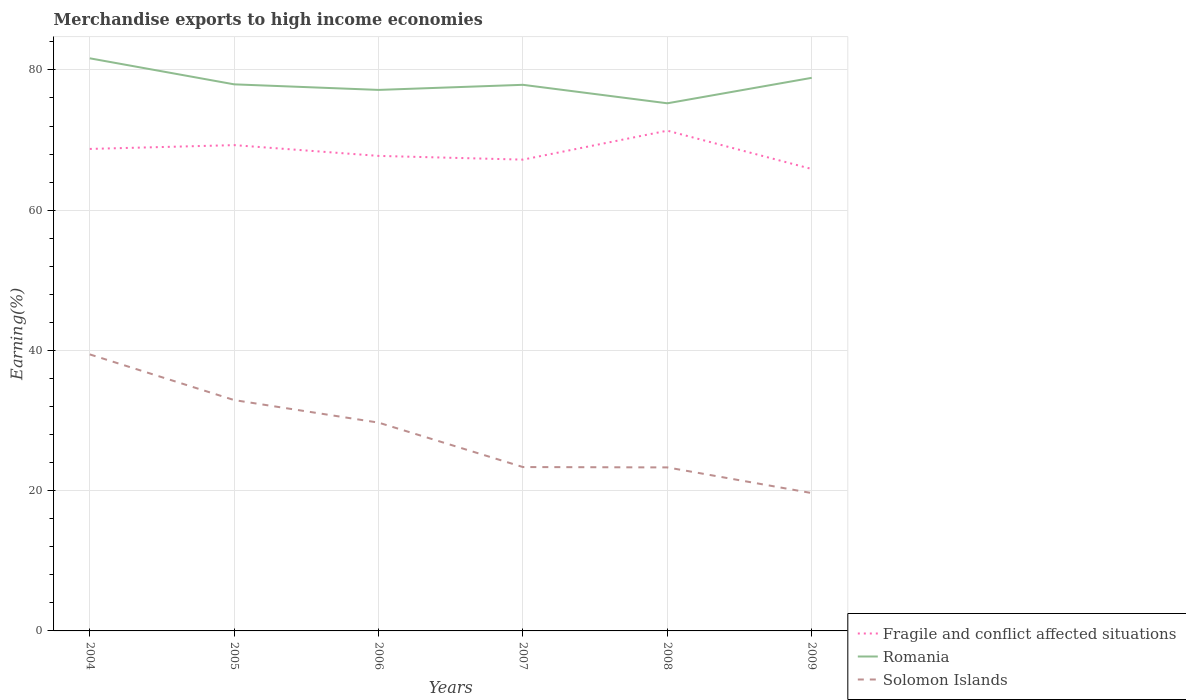Across all years, what is the maximum percentage of amount earned from merchandise exports in Solomon Islands?
Make the answer very short. 19.66. In which year was the percentage of amount earned from merchandise exports in Solomon Islands maximum?
Provide a short and direct response. 2009. What is the total percentage of amount earned from merchandise exports in Solomon Islands in the graph?
Give a very brief answer. 16.12. What is the difference between the highest and the second highest percentage of amount earned from merchandise exports in Solomon Islands?
Your answer should be very brief. 19.77. What is the difference between the highest and the lowest percentage of amount earned from merchandise exports in Romania?
Give a very brief answer. 2. Is the percentage of amount earned from merchandise exports in Solomon Islands strictly greater than the percentage of amount earned from merchandise exports in Romania over the years?
Offer a very short reply. Yes. How many years are there in the graph?
Make the answer very short. 6. Are the values on the major ticks of Y-axis written in scientific E-notation?
Your answer should be compact. No. Does the graph contain any zero values?
Your response must be concise. No. How are the legend labels stacked?
Ensure brevity in your answer.  Vertical. What is the title of the graph?
Ensure brevity in your answer.  Merchandise exports to high income economies. What is the label or title of the Y-axis?
Ensure brevity in your answer.  Earning(%). What is the Earning(%) of Fragile and conflict affected situations in 2004?
Offer a terse response. 68.73. What is the Earning(%) of Romania in 2004?
Keep it short and to the point. 81.66. What is the Earning(%) of Solomon Islands in 2004?
Make the answer very short. 39.43. What is the Earning(%) of Fragile and conflict affected situations in 2005?
Keep it short and to the point. 69.28. What is the Earning(%) of Romania in 2005?
Provide a short and direct response. 77.94. What is the Earning(%) of Solomon Islands in 2005?
Your answer should be compact. 32.92. What is the Earning(%) in Fragile and conflict affected situations in 2006?
Make the answer very short. 67.74. What is the Earning(%) of Romania in 2006?
Your answer should be very brief. 77.15. What is the Earning(%) in Solomon Islands in 2006?
Provide a succinct answer. 29.7. What is the Earning(%) of Fragile and conflict affected situations in 2007?
Make the answer very short. 67.21. What is the Earning(%) in Romania in 2007?
Provide a succinct answer. 77.88. What is the Earning(%) in Solomon Islands in 2007?
Give a very brief answer. 23.37. What is the Earning(%) of Fragile and conflict affected situations in 2008?
Give a very brief answer. 71.34. What is the Earning(%) in Romania in 2008?
Provide a short and direct response. 75.24. What is the Earning(%) in Solomon Islands in 2008?
Provide a short and direct response. 23.32. What is the Earning(%) of Fragile and conflict affected situations in 2009?
Offer a terse response. 65.87. What is the Earning(%) of Romania in 2009?
Give a very brief answer. 78.87. What is the Earning(%) of Solomon Islands in 2009?
Make the answer very short. 19.66. Across all years, what is the maximum Earning(%) of Fragile and conflict affected situations?
Make the answer very short. 71.34. Across all years, what is the maximum Earning(%) in Romania?
Provide a succinct answer. 81.66. Across all years, what is the maximum Earning(%) in Solomon Islands?
Your response must be concise. 39.43. Across all years, what is the minimum Earning(%) in Fragile and conflict affected situations?
Offer a very short reply. 65.87. Across all years, what is the minimum Earning(%) of Romania?
Ensure brevity in your answer.  75.24. Across all years, what is the minimum Earning(%) of Solomon Islands?
Ensure brevity in your answer.  19.66. What is the total Earning(%) in Fragile and conflict affected situations in the graph?
Provide a short and direct response. 410.17. What is the total Earning(%) of Romania in the graph?
Give a very brief answer. 468.74. What is the total Earning(%) of Solomon Islands in the graph?
Ensure brevity in your answer.  168.4. What is the difference between the Earning(%) in Fragile and conflict affected situations in 2004 and that in 2005?
Give a very brief answer. -0.54. What is the difference between the Earning(%) in Romania in 2004 and that in 2005?
Provide a short and direct response. 3.71. What is the difference between the Earning(%) in Solomon Islands in 2004 and that in 2005?
Give a very brief answer. 6.51. What is the difference between the Earning(%) of Fragile and conflict affected situations in 2004 and that in 2006?
Offer a terse response. 0.99. What is the difference between the Earning(%) of Romania in 2004 and that in 2006?
Your answer should be very brief. 4.5. What is the difference between the Earning(%) of Solomon Islands in 2004 and that in 2006?
Your answer should be compact. 9.73. What is the difference between the Earning(%) of Fragile and conflict affected situations in 2004 and that in 2007?
Your answer should be very brief. 1.53. What is the difference between the Earning(%) in Romania in 2004 and that in 2007?
Your answer should be very brief. 3.78. What is the difference between the Earning(%) of Solomon Islands in 2004 and that in 2007?
Give a very brief answer. 16.06. What is the difference between the Earning(%) of Fragile and conflict affected situations in 2004 and that in 2008?
Offer a very short reply. -2.6. What is the difference between the Earning(%) in Romania in 2004 and that in 2008?
Your response must be concise. 6.41. What is the difference between the Earning(%) in Solomon Islands in 2004 and that in 2008?
Ensure brevity in your answer.  16.12. What is the difference between the Earning(%) in Fragile and conflict affected situations in 2004 and that in 2009?
Your answer should be compact. 2.86. What is the difference between the Earning(%) of Romania in 2004 and that in 2009?
Provide a short and direct response. 2.78. What is the difference between the Earning(%) of Solomon Islands in 2004 and that in 2009?
Make the answer very short. 19.77. What is the difference between the Earning(%) of Fragile and conflict affected situations in 2005 and that in 2006?
Offer a terse response. 1.54. What is the difference between the Earning(%) in Romania in 2005 and that in 2006?
Your answer should be very brief. 0.79. What is the difference between the Earning(%) of Solomon Islands in 2005 and that in 2006?
Make the answer very short. 3.21. What is the difference between the Earning(%) in Fragile and conflict affected situations in 2005 and that in 2007?
Offer a very short reply. 2.07. What is the difference between the Earning(%) of Romania in 2005 and that in 2007?
Provide a short and direct response. 0.07. What is the difference between the Earning(%) in Solomon Islands in 2005 and that in 2007?
Ensure brevity in your answer.  9.55. What is the difference between the Earning(%) of Fragile and conflict affected situations in 2005 and that in 2008?
Give a very brief answer. -2.06. What is the difference between the Earning(%) of Romania in 2005 and that in 2008?
Provide a succinct answer. 2.7. What is the difference between the Earning(%) of Solomon Islands in 2005 and that in 2008?
Your answer should be very brief. 9.6. What is the difference between the Earning(%) of Fragile and conflict affected situations in 2005 and that in 2009?
Keep it short and to the point. 3.4. What is the difference between the Earning(%) in Romania in 2005 and that in 2009?
Provide a short and direct response. -0.93. What is the difference between the Earning(%) of Solomon Islands in 2005 and that in 2009?
Keep it short and to the point. 13.26. What is the difference between the Earning(%) of Fragile and conflict affected situations in 2006 and that in 2007?
Provide a short and direct response. 0.53. What is the difference between the Earning(%) in Romania in 2006 and that in 2007?
Offer a very short reply. -0.73. What is the difference between the Earning(%) of Solomon Islands in 2006 and that in 2007?
Offer a terse response. 6.34. What is the difference between the Earning(%) of Fragile and conflict affected situations in 2006 and that in 2008?
Provide a short and direct response. -3.6. What is the difference between the Earning(%) in Romania in 2006 and that in 2008?
Provide a succinct answer. 1.91. What is the difference between the Earning(%) in Solomon Islands in 2006 and that in 2008?
Your answer should be very brief. 6.39. What is the difference between the Earning(%) in Fragile and conflict affected situations in 2006 and that in 2009?
Provide a succinct answer. 1.87. What is the difference between the Earning(%) of Romania in 2006 and that in 2009?
Your response must be concise. -1.72. What is the difference between the Earning(%) of Solomon Islands in 2006 and that in 2009?
Provide a succinct answer. 10.05. What is the difference between the Earning(%) in Fragile and conflict affected situations in 2007 and that in 2008?
Ensure brevity in your answer.  -4.13. What is the difference between the Earning(%) in Romania in 2007 and that in 2008?
Your answer should be compact. 2.63. What is the difference between the Earning(%) of Solomon Islands in 2007 and that in 2008?
Provide a short and direct response. 0.05. What is the difference between the Earning(%) in Fragile and conflict affected situations in 2007 and that in 2009?
Give a very brief answer. 1.33. What is the difference between the Earning(%) of Romania in 2007 and that in 2009?
Your response must be concise. -1. What is the difference between the Earning(%) in Solomon Islands in 2007 and that in 2009?
Provide a succinct answer. 3.71. What is the difference between the Earning(%) in Fragile and conflict affected situations in 2008 and that in 2009?
Your answer should be compact. 5.46. What is the difference between the Earning(%) in Romania in 2008 and that in 2009?
Your answer should be compact. -3.63. What is the difference between the Earning(%) in Solomon Islands in 2008 and that in 2009?
Your response must be concise. 3.66. What is the difference between the Earning(%) in Fragile and conflict affected situations in 2004 and the Earning(%) in Romania in 2005?
Make the answer very short. -9.21. What is the difference between the Earning(%) in Fragile and conflict affected situations in 2004 and the Earning(%) in Solomon Islands in 2005?
Your answer should be very brief. 35.82. What is the difference between the Earning(%) in Romania in 2004 and the Earning(%) in Solomon Islands in 2005?
Your response must be concise. 48.74. What is the difference between the Earning(%) of Fragile and conflict affected situations in 2004 and the Earning(%) of Romania in 2006?
Offer a terse response. -8.42. What is the difference between the Earning(%) of Fragile and conflict affected situations in 2004 and the Earning(%) of Solomon Islands in 2006?
Make the answer very short. 39.03. What is the difference between the Earning(%) in Romania in 2004 and the Earning(%) in Solomon Islands in 2006?
Ensure brevity in your answer.  51.95. What is the difference between the Earning(%) of Fragile and conflict affected situations in 2004 and the Earning(%) of Romania in 2007?
Your response must be concise. -9.14. What is the difference between the Earning(%) of Fragile and conflict affected situations in 2004 and the Earning(%) of Solomon Islands in 2007?
Provide a short and direct response. 45.37. What is the difference between the Earning(%) in Romania in 2004 and the Earning(%) in Solomon Islands in 2007?
Your response must be concise. 58.29. What is the difference between the Earning(%) of Fragile and conflict affected situations in 2004 and the Earning(%) of Romania in 2008?
Provide a succinct answer. -6.51. What is the difference between the Earning(%) of Fragile and conflict affected situations in 2004 and the Earning(%) of Solomon Islands in 2008?
Provide a short and direct response. 45.42. What is the difference between the Earning(%) of Romania in 2004 and the Earning(%) of Solomon Islands in 2008?
Make the answer very short. 58.34. What is the difference between the Earning(%) of Fragile and conflict affected situations in 2004 and the Earning(%) of Romania in 2009?
Provide a short and direct response. -10.14. What is the difference between the Earning(%) in Fragile and conflict affected situations in 2004 and the Earning(%) in Solomon Islands in 2009?
Your answer should be very brief. 49.08. What is the difference between the Earning(%) of Romania in 2004 and the Earning(%) of Solomon Islands in 2009?
Provide a short and direct response. 62. What is the difference between the Earning(%) in Fragile and conflict affected situations in 2005 and the Earning(%) in Romania in 2006?
Offer a very short reply. -7.88. What is the difference between the Earning(%) in Fragile and conflict affected situations in 2005 and the Earning(%) in Solomon Islands in 2006?
Provide a succinct answer. 39.57. What is the difference between the Earning(%) of Romania in 2005 and the Earning(%) of Solomon Islands in 2006?
Provide a succinct answer. 48.24. What is the difference between the Earning(%) in Fragile and conflict affected situations in 2005 and the Earning(%) in Romania in 2007?
Offer a very short reply. -8.6. What is the difference between the Earning(%) of Fragile and conflict affected situations in 2005 and the Earning(%) of Solomon Islands in 2007?
Provide a short and direct response. 45.91. What is the difference between the Earning(%) in Romania in 2005 and the Earning(%) in Solomon Islands in 2007?
Ensure brevity in your answer.  54.58. What is the difference between the Earning(%) of Fragile and conflict affected situations in 2005 and the Earning(%) of Romania in 2008?
Make the answer very short. -5.97. What is the difference between the Earning(%) of Fragile and conflict affected situations in 2005 and the Earning(%) of Solomon Islands in 2008?
Ensure brevity in your answer.  45.96. What is the difference between the Earning(%) of Romania in 2005 and the Earning(%) of Solomon Islands in 2008?
Ensure brevity in your answer.  54.63. What is the difference between the Earning(%) of Fragile and conflict affected situations in 2005 and the Earning(%) of Romania in 2009?
Provide a succinct answer. -9.6. What is the difference between the Earning(%) in Fragile and conflict affected situations in 2005 and the Earning(%) in Solomon Islands in 2009?
Provide a succinct answer. 49.62. What is the difference between the Earning(%) of Romania in 2005 and the Earning(%) of Solomon Islands in 2009?
Offer a very short reply. 58.28. What is the difference between the Earning(%) of Fragile and conflict affected situations in 2006 and the Earning(%) of Romania in 2007?
Ensure brevity in your answer.  -10.14. What is the difference between the Earning(%) of Fragile and conflict affected situations in 2006 and the Earning(%) of Solomon Islands in 2007?
Your answer should be very brief. 44.37. What is the difference between the Earning(%) in Romania in 2006 and the Earning(%) in Solomon Islands in 2007?
Make the answer very short. 53.78. What is the difference between the Earning(%) in Fragile and conflict affected situations in 2006 and the Earning(%) in Romania in 2008?
Provide a short and direct response. -7.5. What is the difference between the Earning(%) in Fragile and conflict affected situations in 2006 and the Earning(%) in Solomon Islands in 2008?
Offer a terse response. 44.42. What is the difference between the Earning(%) of Romania in 2006 and the Earning(%) of Solomon Islands in 2008?
Provide a succinct answer. 53.83. What is the difference between the Earning(%) in Fragile and conflict affected situations in 2006 and the Earning(%) in Romania in 2009?
Ensure brevity in your answer.  -11.13. What is the difference between the Earning(%) in Fragile and conflict affected situations in 2006 and the Earning(%) in Solomon Islands in 2009?
Offer a terse response. 48.08. What is the difference between the Earning(%) in Romania in 2006 and the Earning(%) in Solomon Islands in 2009?
Your response must be concise. 57.49. What is the difference between the Earning(%) of Fragile and conflict affected situations in 2007 and the Earning(%) of Romania in 2008?
Keep it short and to the point. -8.03. What is the difference between the Earning(%) of Fragile and conflict affected situations in 2007 and the Earning(%) of Solomon Islands in 2008?
Offer a terse response. 43.89. What is the difference between the Earning(%) in Romania in 2007 and the Earning(%) in Solomon Islands in 2008?
Make the answer very short. 54.56. What is the difference between the Earning(%) of Fragile and conflict affected situations in 2007 and the Earning(%) of Romania in 2009?
Your response must be concise. -11.67. What is the difference between the Earning(%) in Fragile and conflict affected situations in 2007 and the Earning(%) in Solomon Islands in 2009?
Offer a very short reply. 47.55. What is the difference between the Earning(%) of Romania in 2007 and the Earning(%) of Solomon Islands in 2009?
Offer a terse response. 58.22. What is the difference between the Earning(%) in Fragile and conflict affected situations in 2008 and the Earning(%) in Romania in 2009?
Provide a succinct answer. -7.54. What is the difference between the Earning(%) of Fragile and conflict affected situations in 2008 and the Earning(%) of Solomon Islands in 2009?
Offer a terse response. 51.68. What is the difference between the Earning(%) in Romania in 2008 and the Earning(%) in Solomon Islands in 2009?
Your answer should be very brief. 55.58. What is the average Earning(%) in Fragile and conflict affected situations per year?
Provide a short and direct response. 68.36. What is the average Earning(%) in Romania per year?
Make the answer very short. 78.12. What is the average Earning(%) in Solomon Islands per year?
Offer a very short reply. 28.07. In the year 2004, what is the difference between the Earning(%) of Fragile and conflict affected situations and Earning(%) of Romania?
Keep it short and to the point. -12.92. In the year 2004, what is the difference between the Earning(%) in Fragile and conflict affected situations and Earning(%) in Solomon Islands?
Offer a very short reply. 29.3. In the year 2004, what is the difference between the Earning(%) of Romania and Earning(%) of Solomon Islands?
Make the answer very short. 42.22. In the year 2005, what is the difference between the Earning(%) in Fragile and conflict affected situations and Earning(%) in Romania?
Offer a terse response. -8.67. In the year 2005, what is the difference between the Earning(%) in Fragile and conflict affected situations and Earning(%) in Solomon Islands?
Provide a short and direct response. 36.36. In the year 2005, what is the difference between the Earning(%) in Romania and Earning(%) in Solomon Islands?
Offer a terse response. 45.02. In the year 2006, what is the difference between the Earning(%) in Fragile and conflict affected situations and Earning(%) in Romania?
Your answer should be very brief. -9.41. In the year 2006, what is the difference between the Earning(%) of Fragile and conflict affected situations and Earning(%) of Solomon Islands?
Provide a succinct answer. 38.04. In the year 2006, what is the difference between the Earning(%) in Romania and Earning(%) in Solomon Islands?
Keep it short and to the point. 47.45. In the year 2007, what is the difference between the Earning(%) of Fragile and conflict affected situations and Earning(%) of Romania?
Offer a terse response. -10.67. In the year 2007, what is the difference between the Earning(%) of Fragile and conflict affected situations and Earning(%) of Solomon Islands?
Offer a very short reply. 43.84. In the year 2007, what is the difference between the Earning(%) of Romania and Earning(%) of Solomon Islands?
Provide a short and direct response. 54.51. In the year 2008, what is the difference between the Earning(%) of Fragile and conflict affected situations and Earning(%) of Romania?
Keep it short and to the point. -3.9. In the year 2008, what is the difference between the Earning(%) of Fragile and conflict affected situations and Earning(%) of Solomon Islands?
Give a very brief answer. 48.02. In the year 2008, what is the difference between the Earning(%) of Romania and Earning(%) of Solomon Islands?
Keep it short and to the point. 51.92. In the year 2009, what is the difference between the Earning(%) of Fragile and conflict affected situations and Earning(%) of Romania?
Provide a succinct answer. -13. In the year 2009, what is the difference between the Earning(%) of Fragile and conflict affected situations and Earning(%) of Solomon Islands?
Give a very brief answer. 46.21. In the year 2009, what is the difference between the Earning(%) of Romania and Earning(%) of Solomon Islands?
Your response must be concise. 59.21. What is the ratio of the Earning(%) in Fragile and conflict affected situations in 2004 to that in 2005?
Give a very brief answer. 0.99. What is the ratio of the Earning(%) of Romania in 2004 to that in 2005?
Keep it short and to the point. 1.05. What is the ratio of the Earning(%) in Solomon Islands in 2004 to that in 2005?
Your answer should be compact. 1.2. What is the ratio of the Earning(%) of Fragile and conflict affected situations in 2004 to that in 2006?
Provide a succinct answer. 1.01. What is the ratio of the Earning(%) in Romania in 2004 to that in 2006?
Your answer should be very brief. 1.06. What is the ratio of the Earning(%) of Solomon Islands in 2004 to that in 2006?
Offer a terse response. 1.33. What is the ratio of the Earning(%) of Fragile and conflict affected situations in 2004 to that in 2007?
Give a very brief answer. 1.02. What is the ratio of the Earning(%) of Romania in 2004 to that in 2007?
Your answer should be very brief. 1.05. What is the ratio of the Earning(%) of Solomon Islands in 2004 to that in 2007?
Give a very brief answer. 1.69. What is the ratio of the Earning(%) in Fragile and conflict affected situations in 2004 to that in 2008?
Ensure brevity in your answer.  0.96. What is the ratio of the Earning(%) in Romania in 2004 to that in 2008?
Make the answer very short. 1.09. What is the ratio of the Earning(%) in Solomon Islands in 2004 to that in 2008?
Ensure brevity in your answer.  1.69. What is the ratio of the Earning(%) in Fragile and conflict affected situations in 2004 to that in 2009?
Provide a succinct answer. 1.04. What is the ratio of the Earning(%) of Romania in 2004 to that in 2009?
Your answer should be very brief. 1.04. What is the ratio of the Earning(%) in Solomon Islands in 2004 to that in 2009?
Give a very brief answer. 2.01. What is the ratio of the Earning(%) in Fragile and conflict affected situations in 2005 to that in 2006?
Make the answer very short. 1.02. What is the ratio of the Earning(%) of Romania in 2005 to that in 2006?
Give a very brief answer. 1.01. What is the ratio of the Earning(%) in Solomon Islands in 2005 to that in 2006?
Offer a very short reply. 1.11. What is the ratio of the Earning(%) of Fragile and conflict affected situations in 2005 to that in 2007?
Your response must be concise. 1.03. What is the ratio of the Earning(%) in Romania in 2005 to that in 2007?
Your response must be concise. 1. What is the ratio of the Earning(%) of Solomon Islands in 2005 to that in 2007?
Give a very brief answer. 1.41. What is the ratio of the Earning(%) in Fragile and conflict affected situations in 2005 to that in 2008?
Provide a short and direct response. 0.97. What is the ratio of the Earning(%) of Romania in 2005 to that in 2008?
Offer a terse response. 1.04. What is the ratio of the Earning(%) of Solomon Islands in 2005 to that in 2008?
Your answer should be compact. 1.41. What is the ratio of the Earning(%) of Fragile and conflict affected situations in 2005 to that in 2009?
Ensure brevity in your answer.  1.05. What is the ratio of the Earning(%) in Solomon Islands in 2005 to that in 2009?
Provide a short and direct response. 1.67. What is the ratio of the Earning(%) in Fragile and conflict affected situations in 2006 to that in 2007?
Your answer should be very brief. 1.01. What is the ratio of the Earning(%) of Solomon Islands in 2006 to that in 2007?
Your response must be concise. 1.27. What is the ratio of the Earning(%) in Fragile and conflict affected situations in 2006 to that in 2008?
Your answer should be very brief. 0.95. What is the ratio of the Earning(%) in Romania in 2006 to that in 2008?
Your answer should be very brief. 1.03. What is the ratio of the Earning(%) of Solomon Islands in 2006 to that in 2008?
Ensure brevity in your answer.  1.27. What is the ratio of the Earning(%) in Fragile and conflict affected situations in 2006 to that in 2009?
Your answer should be very brief. 1.03. What is the ratio of the Earning(%) of Romania in 2006 to that in 2009?
Keep it short and to the point. 0.98. What is the ratio of the Earning(%) of Solomon Islands in 2006 to that in 2009?
Give a very brief answer. 1.51. What is the ratio of the Earning(%) in Fragile and conflict affected situations in 2007 to that in 2008?
Make the answer very short. 0.94. What is the ratio of the Earning(%) of Romania in 2007 to that in 2008?
Make the answer very short. 1.03. What is the ratio of the Earning(%) of Solomon Islands in 2007 to that in 2008?
Provide a succinct answer. 1. What is the ratio of the Earning(%) in Fragile and conflict affected situations in 2007 to that in 2009?
Give a very brief answer. 1.02. What is the ratio of the Earning(%) of Romania in 2007 to that in 2009?
Your response must be concise. 0.99. What is the ratio of the Earning(%) in Solomon Islands in 2007 to that in 2009?
Keep it short and to the point. 1.19. What is the ratio of the Earning(%) of Fragile and conflict affected situations in 2008 to that in 2009?
Offer a very short reply. 1.08. What is the ratio of the Earning(%) in Romania in 2008 to that in 2009?
Your answer should be compact. 0.95. What is the ratio of the Earning(%) in Solomon Islands in 2008 to that in 2009?
Give a very brief answer. 1.19. What is the difference between the highest and the second highest Earning(%) of Fragile and conflict affected situations?
Ensure brevity in your answer.  2.06. What is the difference between the highest and the second highest Earning(%) of Romania?
Your answer should be very brief. 2.78. What is the difference between the highest and the second highest Earning(%) of Solomon Islands?
Give a very brief answer. 6.51. What is the difference between the highest and the lowest Earning(%) of Fragile and conflict affected situations?
Provide a short and direct response. 5.46. What is the difference between the highest and the lowest Earning(%) of Romania?
Offer a very short reply. 6.41. What is the difference between the highest and the lowest Earning(%) in Solomon Islands?
Offer a very short reply. 19.77. 